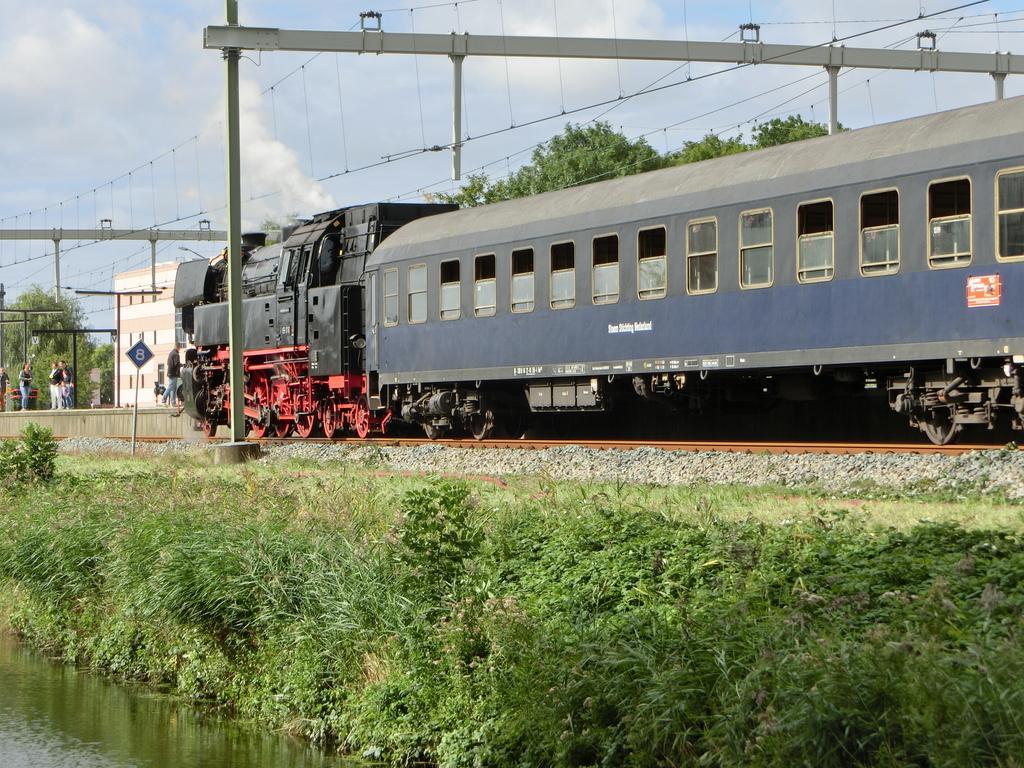Describe this image in one or two sentences. In this image there is track, on that track there is a train, on top of the train there are electrical wire and poles, on the left there is a lake and grass, in the background there are people and trees. 